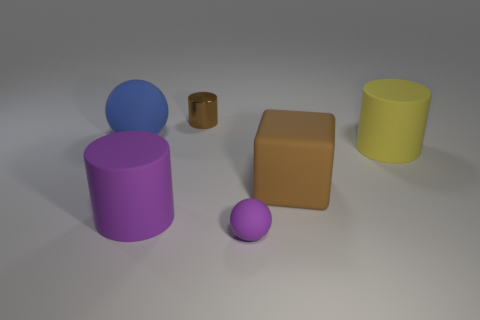There is a tiny matte thing; is it the same color as the big cylinder left of the brown matte block?
Offer a very short reply. Yes. What number of other things are the same color as the rubber block?
Your response must be concise. 1. What size is the purple thing that is on the left side of the tiny shiny cylinder?
Your response must be concise. Large. What is the material of the cylinder that is in front of the big rubber cylinder that is right of the brown thing that is in front of the brown metal object?
Your answer should be very brief. Rubber. Do the large purple thing and the brown thing behind the matte block have the same shape?
Offer a terse response. Yes. How many large matte objects are the same shape as the small purple matte thing?
Your answer should be compact. 1. The tiny purple matte object is what shape?
Provide a succinct answer. Sphere. What is the size of the cylinder that is behind the cylinder that is on the right side of the purple sphere?
Offer a very short reply. Small. How many objects are either large purple objects or tiny blue matte things?
Give a very brief answer. 1. Do the big blue thing and the small purple object have the same shape?
Keep it short and to the point. Yes. 